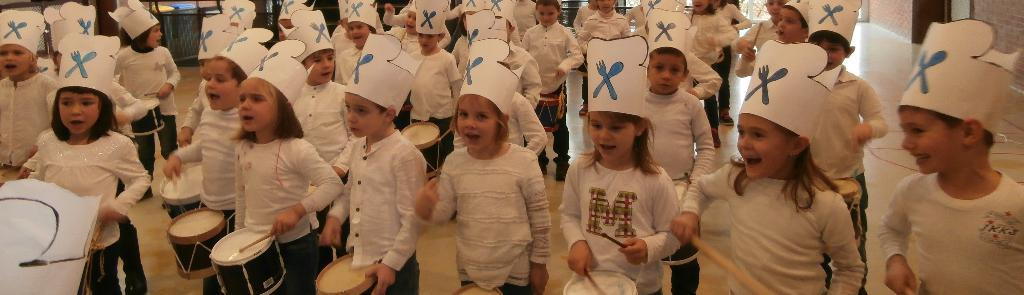What are the boys and girls in the image wearing? The boys and girls in the image are wearing the same attire, including white color caps. What activity are they engaged in? They are playing drums with sticks on the floor. What can be seen in the background of the image? There is a wall visible in the background of the image. Is there a hospital visible in the image? No, there is no hospital present in the image. The image shows boys and girls playing drums with sticks on the floor, wearing white color caps, and there is a wall visible in the background. 